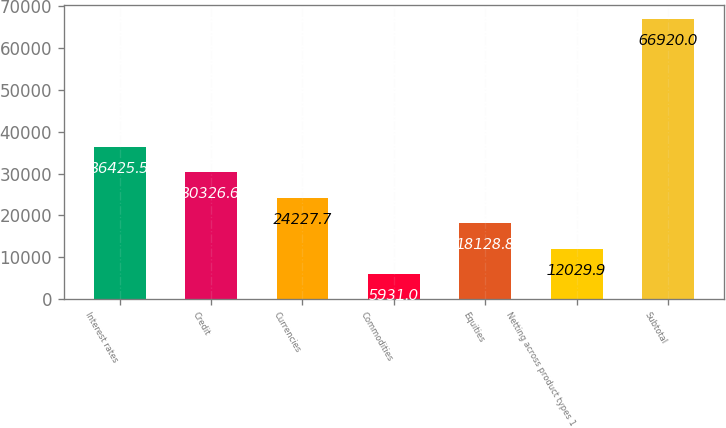Convert chart. <chart><loc_0><loc_0><loc_500><loc_500><bar_chart><fcel>Interest rates<fcel>Credit<fcel>Currencies<fcel>Commodities<fcel>Equities<fcel>Netting across product types 1<fcel>Subtotal<nl><fcel>36425.5<fcel>30326.6<fcel>24227.7<fcel>5931<fcel>18128.8<fcel>12029.9<fcel>66920<nl></chart> 